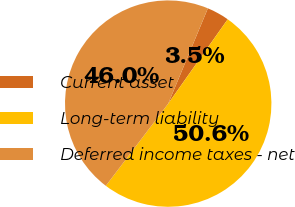<chart> <loc_0><loc_0><loc_500><loc_500><pie_chart><fcel>Current asset<fcel>Long-term liability<fcel>Deferred income taxes - net<nl><fcel>3.5%<fcel>50.55%<fcel>45.95%<nl></chart> 